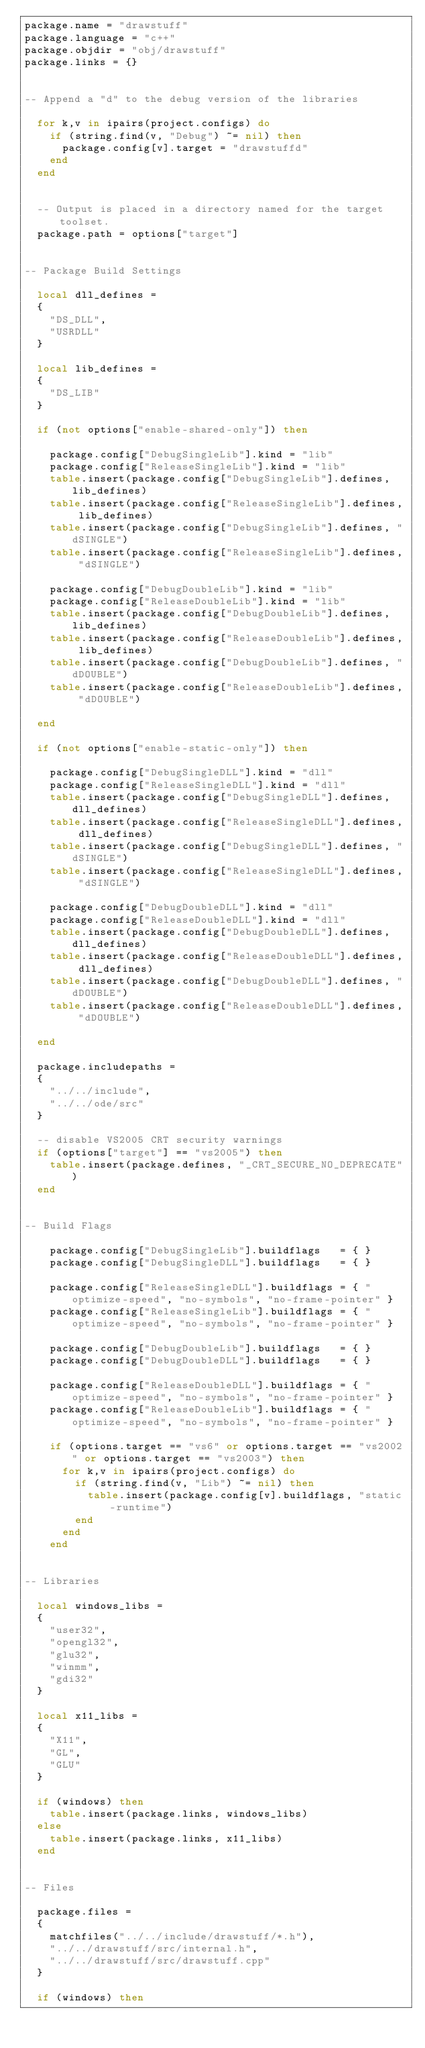<code> <loc_0><loc_0><loc_500><loc_500><_Lua_>package.name = "drawstuff"
package.language = "c++"
package.objdir = "obj/drawstuff"
package.links = {}


-- Append a "d" to the debug version of the libraries

  for k,v in ipairs(project.configs) do
    if (string.find(v, "Debug") ~= nil) then
      package.config[v].target = "drawstuffd"
    end
  end


  -- Output is placed in a directory named for the target toolset.
  package.path = options["target"]


-- Package Build Settings

  local dll_defines =
  {
    "DS_DLL",
    "USRDLL"
  }

  local lib_defines =
  {
    "DS_LIB"
  }

  if (not options["enable-shared-only"]) then

    package.config["DebugSingleLib"].kind = "lib"
    package.config["ReleaseSingleLib"].kind = "lib"
    table.insert(package.config["DebugSingleLib"].defines, lib_defines)
    table.insert(package.config["ReleaseSingleLib"].defines, lib_defines)
    table.insert(package.config["DebugSingleLib"].defines, "dSINGLE")
    table.insert(package.config["ReleaseSingleLib"].defines, "dSINGLE")

    package.config["DebugDoubleLib"].kind = "lib"
    package.config["ReleaseDoubleLib"].kind = "lib"
    table.insert(package.config["DebugDoubleLib"].defines, lib_defines)
    table.insert(package.config["ReleaseDoubleLib"].defines, lib_defines)
    table.insert(package.config["DebugDoubleLib"].defines, "dDOUBLE")
    table.insert(package.config["ReleaseDoubleLib"].defines, "dDOUBLE")

  end

  if (not options["enable-static-only"]) then

    package.config["DebugSingleDLL"].kind = "dll"
    package.config["ReleaseSingleDLL"].kind = "dll"
    table.insert(package.config["DebugSingleDLL"].defines, dll_defines)
    table.insert(package.config["ReleaseSingleDLL"].defines, dll_defines)
    table.insert(package.config["DebugSingleDLL"].defines, "dSINGLE")
    table.insert(package.config["ReleaseSingleDLL"].defines, "dSINGLE")

    package.config["DebugDoubleDLL"].kind = "dll"
    package.config["ReleaseDoubleDLL"].kind = "dll"
    table.insert(package.config["DebugDoubleDLL"].defines, dll_defines)
    table.insert(package.config["ReleaseDoubleDLL"].defines, dll_defines)
    table.insert(package.config["DebugDoubleDLL"].defines, "dDOUBLE")
    table.insert(package.config["ReleaseDoubleDLL"].defines, "dDOUBLE")

  end

  package.includepaths =
  {
    "../../include",
    "../../ode/src"
  }

  -- disable VS2005 CRT security warnings
  if (options["target"] == "vs2005") then
    table.insert(package.defines, "_CRT_SECURE_NO_DEPRECATE")
  end


-- Build Flags

	package.config["DebugSingleLib"].buildflags   = { }
	package.config["DebugSingleDLL"].buildflags   = { }

	package.config["ReleaseSingleDLL"].buildflags = { "optimize-speed", "no-symbols", "no-frame-pointer" }
	package.config["ReleaseSingleLib"].buildflags = { "optimize-speed", "no-symbols", "no-frame-pointer" }

	package.config["DebugDoubleLib"].buildflags   = { }
	package.config["DebugDoubleDLL"].buildflags   = { }

	package.config["ReleaseDoubleDLL"].buildflags = { "optimize-speed", "no-symbols", "no-frame-pointer" }
	package.config["ReleaseDoubleLib"].buildflags = { "optimize-speed", "no-symbols", "no-frame-pointer" }

	if (options.target == "vs6" or options.target == "vs2002" or options.target == "vs2003") then
      for k,v in ipairs(project.configs) do
        if (string.find(v, "Lib") ~= nil) then
          table.insert(package.config[v].buildflags, "static-runtime")
        end
      end
	end


-- Libraries

  local windows_libs =
  {
    "user32",
    "opengl32",
    "glu32",
    "winmm",
    "gdi32"
  }

  local x11_libs =
  {
    "X11",
    "GL",
    "GLU"
  }

  if (windows) then
    table.insert(package.links, windows_libs)
  else
    table.insert(package.links, x11_libs)
  end


-- Files

  package.files =
  {
    matchfiles("../../include/drawstuff/*.h"),
    "../../drawstuff/src/internal.h",
    "../../drawstuff/src/drawstuff.cpp"
  }

  if (windows) then</code> 